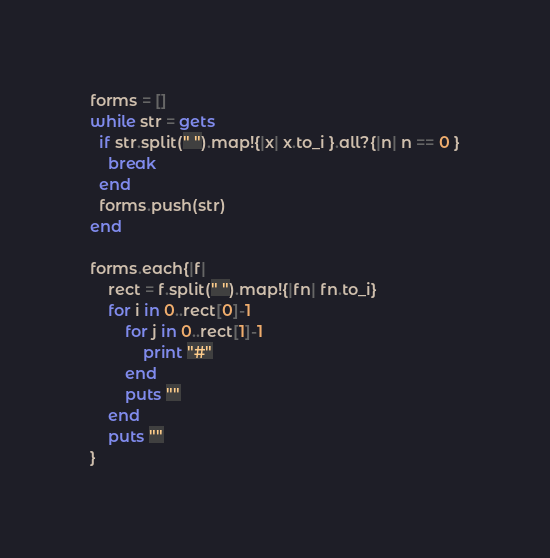Convert code to text. <code><loc_0><loc_0><loc_500><loc_500><_Ruby_>forms = []
while str = gets
  if str.split(" ").map!{|x| x.to_i }.all?{|n| n == 0 }
    break
  end
  forms.push(str)
end

forms.each{|f|
	rect = f.split(" ").map!{|fn| fn.to_i}
	for i in 0..rect[0]-1
		for j in 0..rect[1]-1
			print "#"
		end
		puts ""
	end
	puts ""
}</code> 